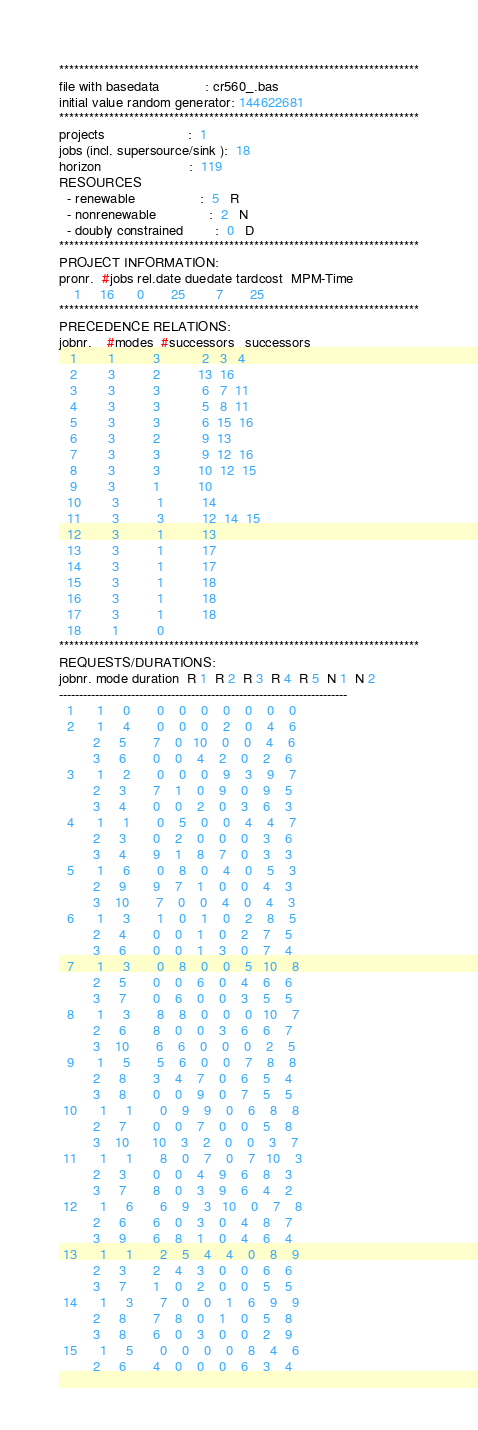<code> <loc_0><loc_0><loc_500><loc_500><_ObjectiveC_>************************************************************************
file with basedata            : cr560_.bas
initial value random generator: 144622681
************************************************************************
projects                      :  1
jobs (incl. supersource/sink ):  18
horizon                       :  119
RESOURCES
  - renewable                 :  5   R
  - nonrenewable              :  2   N
  - doubly constrained        :  0   D
************************************************************************
PROJECT INFORMATION:
pronr.  #jobs rel.date duedate tardcost  MPM-Time
    1     16      0       25        7       25
************************************************************************
PRECEDENCE RELATIONS:
jobnr.    #modes  #successors   successors
   1        1          3           2   3   4
   2        3          2          13  16
   3        3          3           6   7  11
   4        3          3           5   8  11
   5        3          3           6  15  16
   6        3          2           9  13
   7        3          3           9  12  16
   8        3          3          10  12  15
   9        3          1          10
  10        3          1          14
  11        3          3          12  14  15
  12        3          1          13
  13        3          1          17
  14        3          1          17
  15        3          1          18
  16        3          1          18
  17        3          1          18
  18        1          0        
************************************************************************
REQUESTS/DURATIONS:
jobnr. mode duration  R 1  R 2  R 3  R 4  R 5  N 1  N 2
------------------------------------------------------------------------
  1      1     0       0    0    0    0    0    0    0
  2      1     4       0    0    0    2    0    4    6
         2     5       7    0   10    0    0    4    6
         3     6       0    0    4    2    0    2    6
  3      1     2       0    0    0    9    3    9    7
         2     3       7    1    0    9    0    9    5
         3     4       0    0    2    0    3    6    3
  4      1     1       0    5    0    0    4    4    7
         2     3       0    2    0    0    0    3    6
         3     4       9    1    8    7    0    3    3
  5      1     6       0    8    0    4    0    5    3
         2     9       9    7    1    0    0    4    3
         3    10       7    0    0    4    0    4    3
  6      1     3       1    0    1    0    2    8    5
         2     4       0    0    1    0    2    7    5
         3     6       0    0    1    3    0    7    4
  7      1     3       0    8    0    0    5   10    8
         2     5       0    0    6    0    4    6    6
         3     7       0    6    0    0    3    5    5
  8      1     3       8    8    0    0    0   10    7
         2     6       8    0    0    3    6    6    7
         3    10       6    6    0    0    0    2    5
  9      1     5       5    6    0    0    7    8    8
         2     8       3    4    7    0    6    5    4
         3     8       0    0    9    0    7    5    5
 10      1     1       0    9    9    0    6    8    8
         2     7       0    0    7    0    0    5    8
         3    10      10    3    2    0    0    3    7
 11      1     1       8    0    7    0    7   10    3
         2     3       0    0    4    9    6    8    3
         3     7       8    0    3    9    6    4    2
 12      1     6       6    9    3   10    0    7    8
         2     6       6    0    3    0    4    8    7
         3     9       6    8    1    0    4    6    4
 13      1     1       2    5    4    4    0    8    9
         2     3       2    4    3    0    0    6    6
         3     7       1    0    2    0    0    5    5
 14      1     3       7    0    0    1    6    9    9
         2     8       7    8    0    1    0    5    8
         3     8       6    0    3    0    0    2    9
 15      1     5       0    0    0    0    8    4    6
         2     6       4    0    0    0    6    3    4</code> 